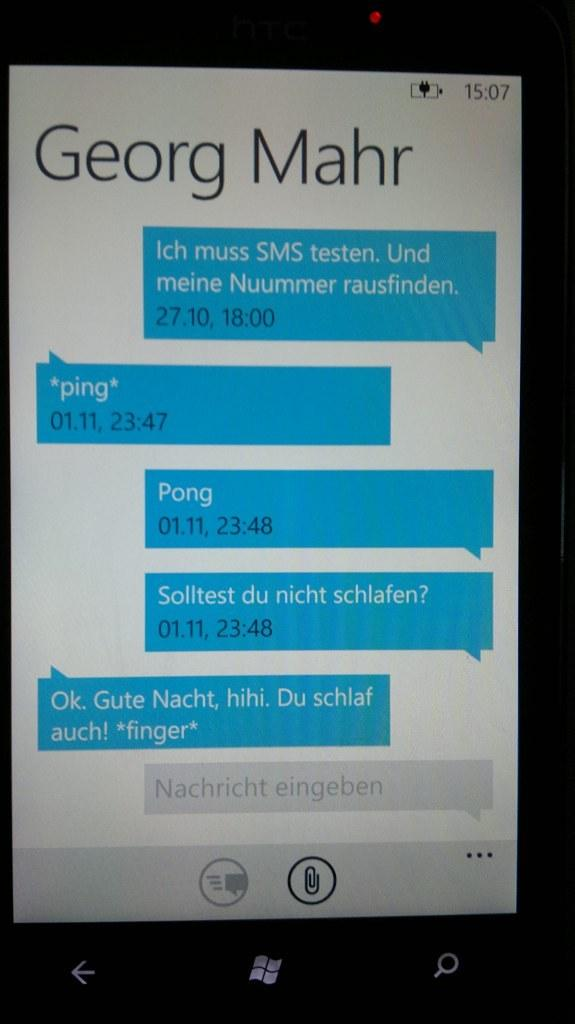<image>
Give a short and clear explanation of the subsequent image. a phone that has messages from Georg Mahr on it 